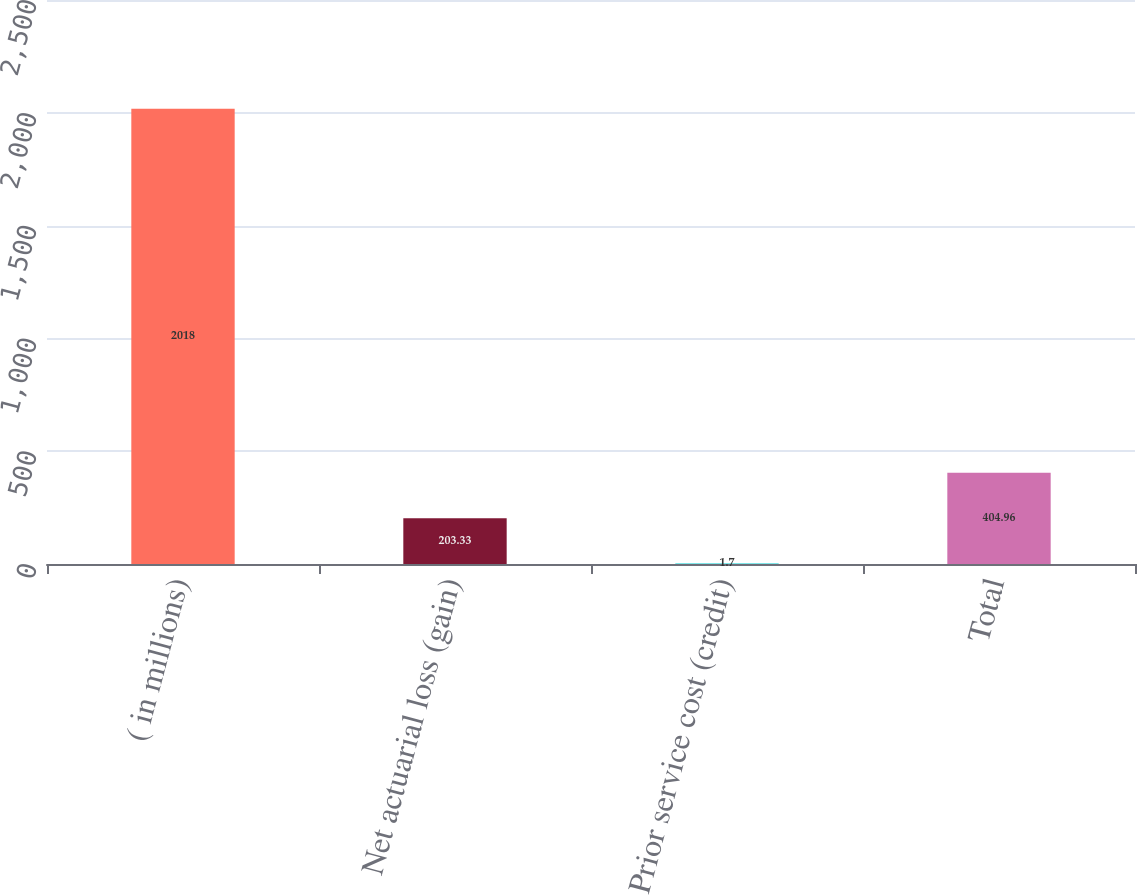<chart> <loc_0><loc_0><loc_500><loc_500><bar_chart><fcel>( in millions)<fcel>Net actuarial loss (gain)<fcel>Prior service cost (credit)<fcel>Total<nl><fcel>2018<fcel>203.33<fcel>1.7<fcel>404.96<nl></chart> 